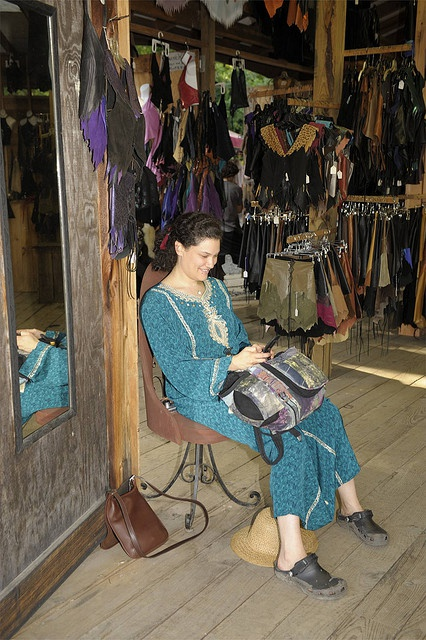Describe the objects in this image and their specific colors. I can see people in gray, teal, and black tones, handbag in gray, darkgray, black, and lightgray tones, backpack in gray, darkgray, black, and lightgray tones, chair in gray and black tones, and cell phone in gray and black tones in this image. 